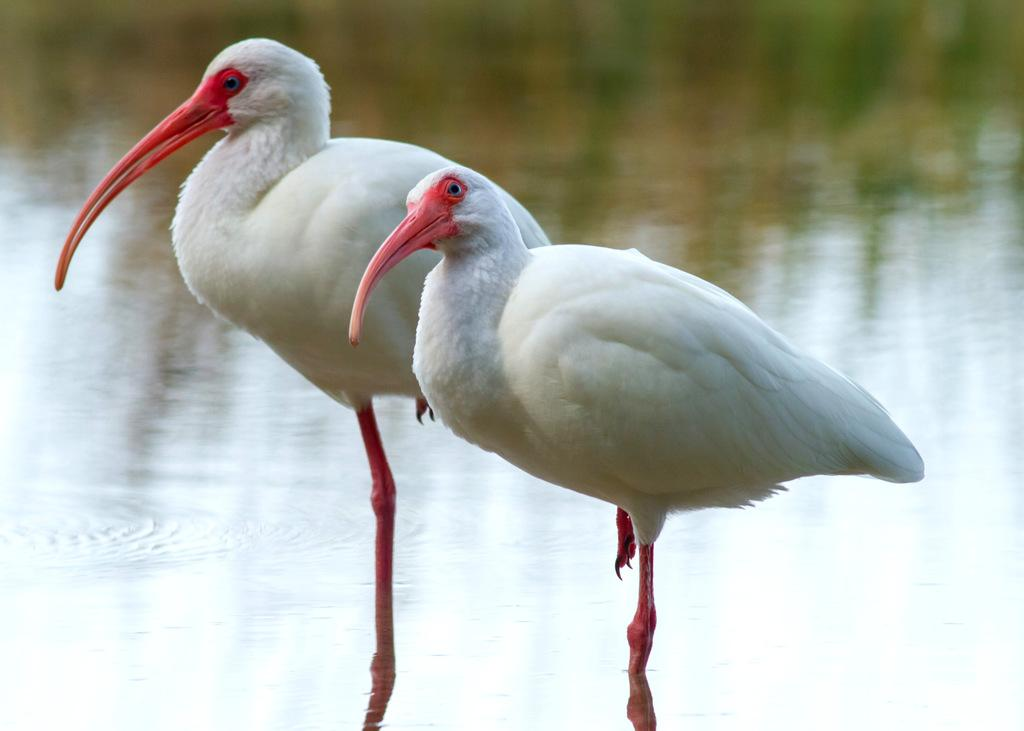How many birds are present in the image? There are two birds in the image. What are the birds doing in the image? The birds are standing beside each other. What can be seen in the background of the image? There is water visible in the background of the image. What type of sticks are the birds using to have a discussion in the image? There are no sticks or discussions present in the image; it features two birds standing beside each other. Can you tell me the name of the mother bird in the image? There is no indication of a mother bird or any bird having offspring in the image. 